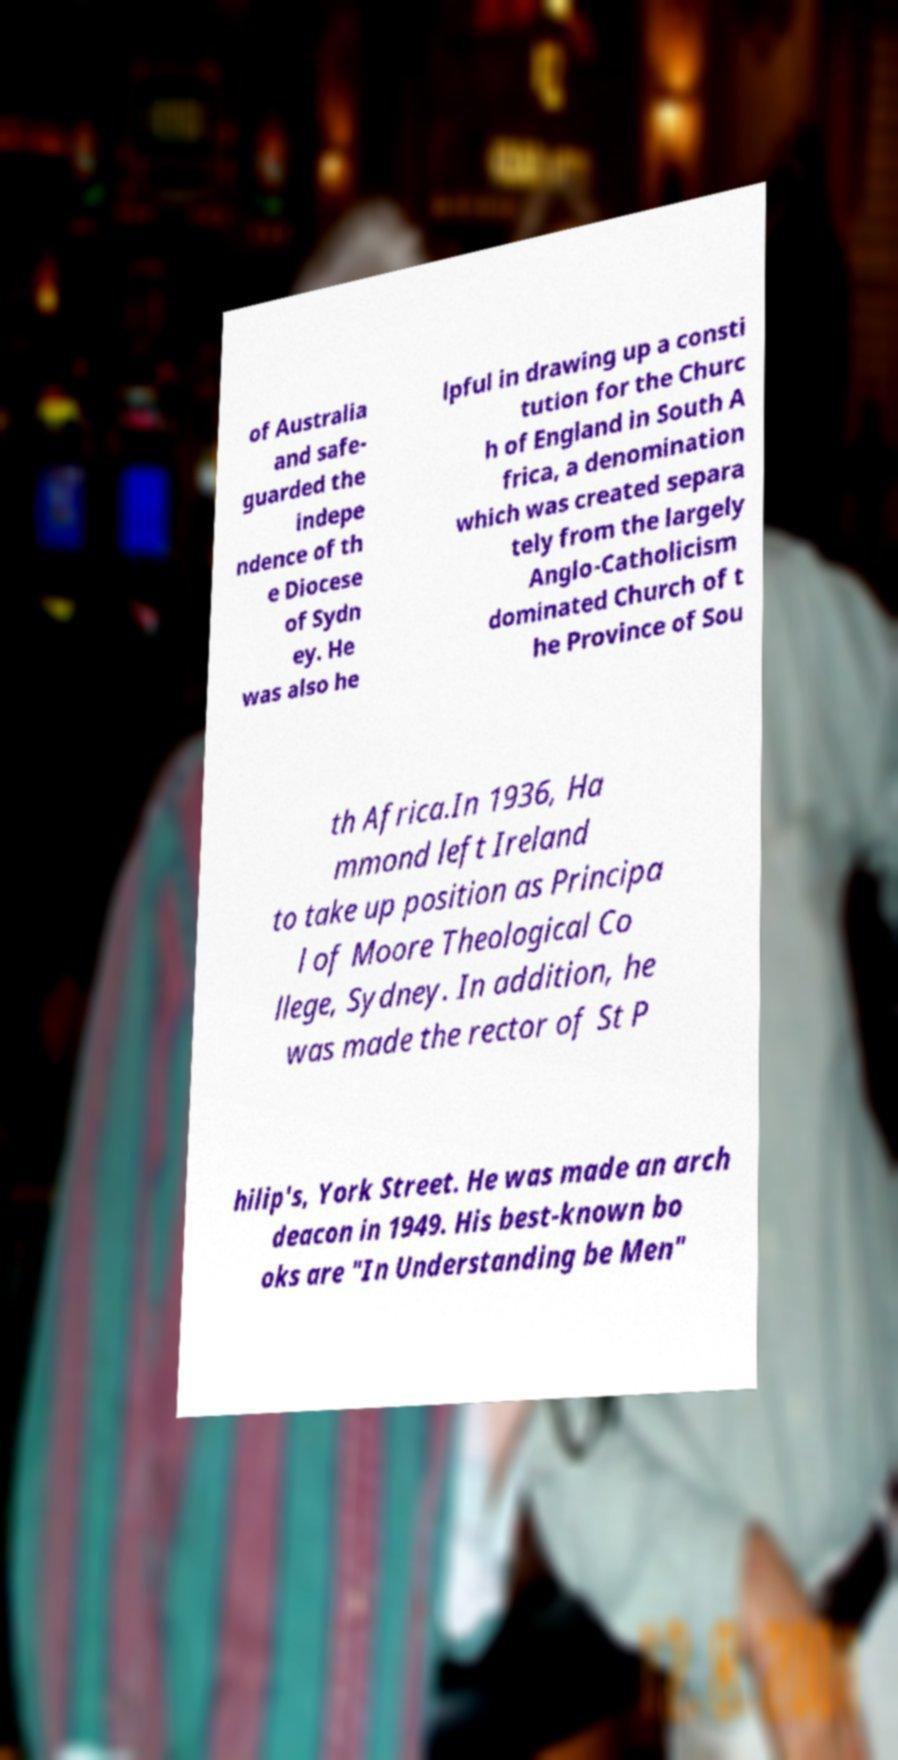Please identify and transcribe the text found in this image. of Australia and safe- guarded the indepe ndence of th e Diocese of Sydn ey. He was also he lpful in drawing up a consti tution for the Churc h of England in South A frica, a denomination which was created separa tely from the largely Anglo-Catholicism dominated Church of t he Province of Sou th Africa.In 1936, Ha mmond left Ireland to take up position as Principa l of Moore Theological Co llege, Sydney. In addition, he was made the rector of St P hilip's, York Street. He was made an arch deacon in 1949. His best-known bo oks are "In Understanding be Men" 